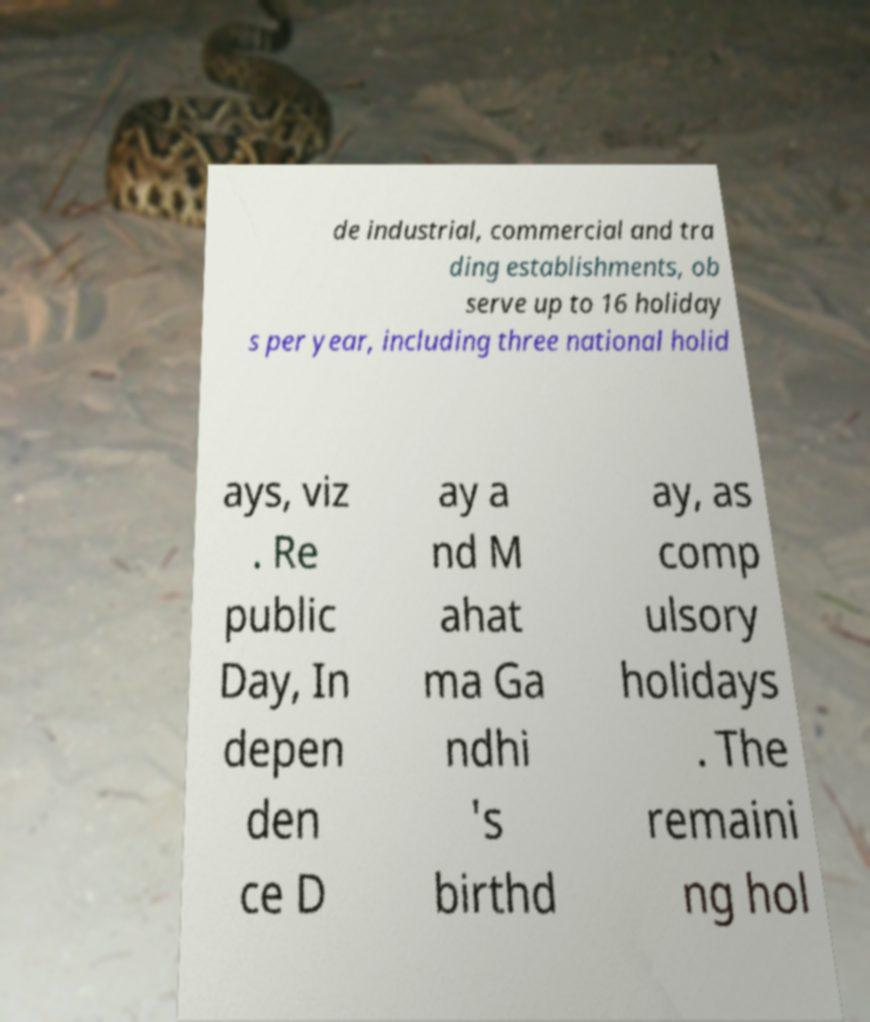I need the written content from this picture converted into text. Can you do that? de industrial, commercial and tra ding establishments, ob serve up to 16 holiday s per year, including three national holid ays, viz . Re public Day, In depen den ce D ay a nd M ahat ma Ga ndhi 's birthd ay, as comp ulsory holidays . The remaini ng hol 